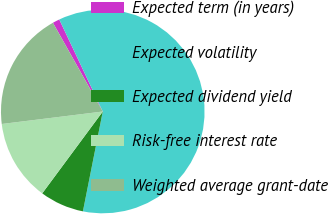<chart> <loc_0><loc_0><loc_500><loc_500><pie_chart><fcel>Expected term (in years)<fcel>Expected volatility<fcel>Expected dividend yield<fcel>Risk-free interest rate<fcel>Weighted average grant-date<nl><fcel>1.12%<fcel>60.15%<fcel>7.01%<fcel>12.91%<fcel>18.81%<nl></chart> 